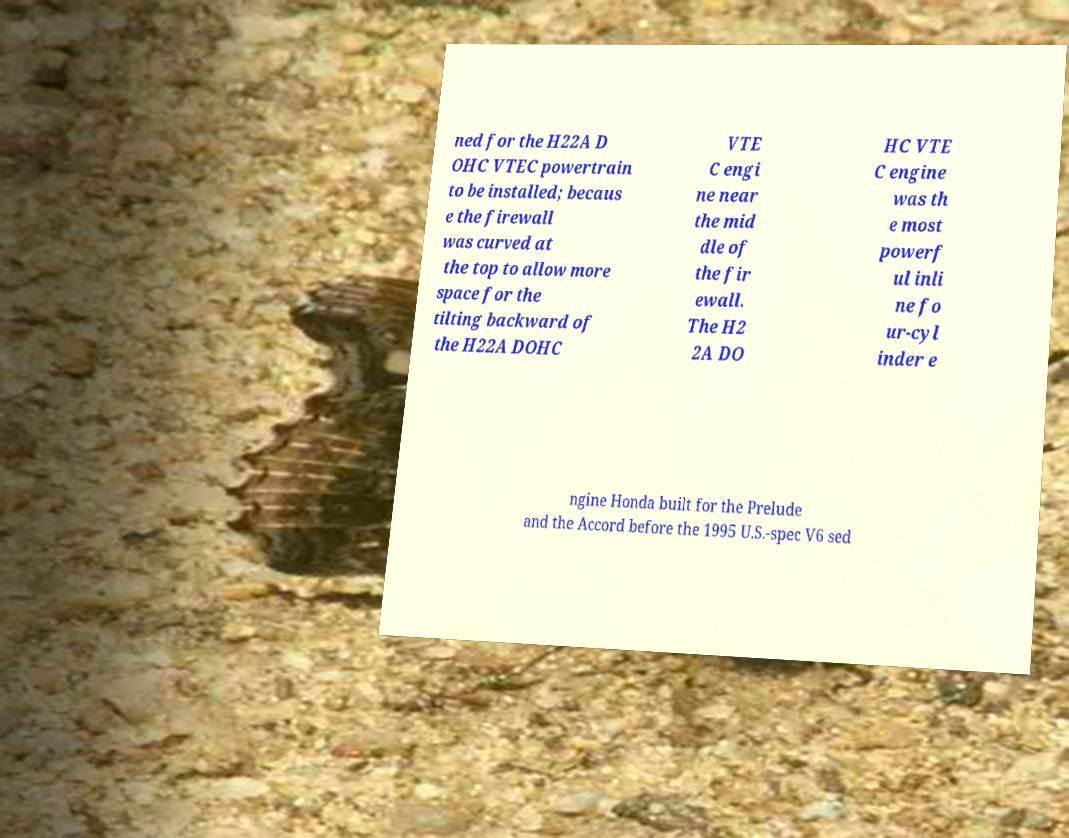For documentation purposes, I need the text within this image transcribed. Could you provide that? ned for the H22A D OHC VTEC powertrain to be installed; becaus e the firewall was curved at the top to allow more space for the tilting backward of the H22A DOHC VTE C engi ne near the mid dle of the fir ewall. The H2 2A DO HC VTE C engine was th e most powerf ul inli ne fo ur-cyl inder e ngine Honda built for the Prelude and the Accord before the 1995 U.S.-spec V6 sed 